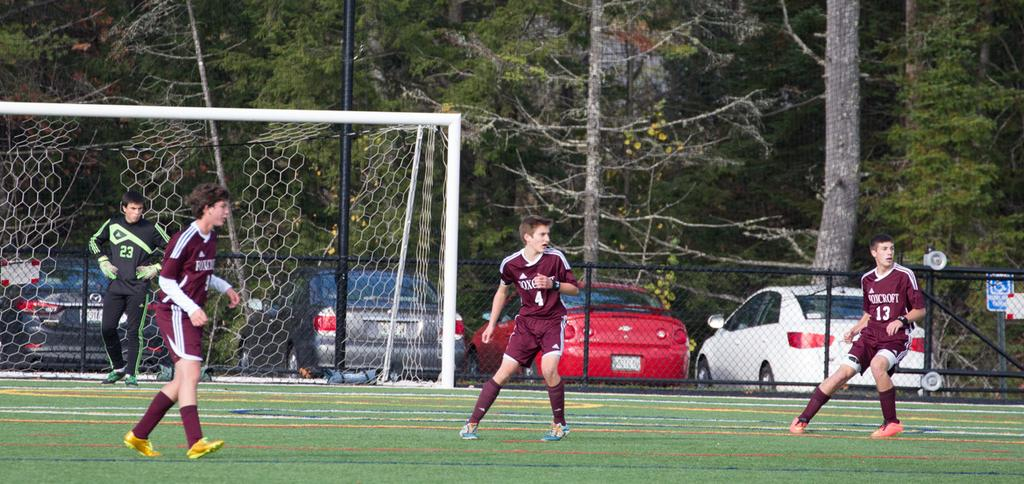What activity are the people in the image engaged in? The people in the image are playing football. Where is the net located in the image? The net is on the left side of the image. What can be seen in the background of the image? There are trees and cars in the background of the image. What type of material is visible in the image? There is a mesh visible in the image. Are there any women playing football with their friends in the image? The provided facts do not mention the gender of the people playing football, nor do they mention any friends. Additionally, there is no mention of chickens in the image. 